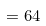<formula> <loc_0><loc_0><loc_500><loc_500>= 6 4</formula> 